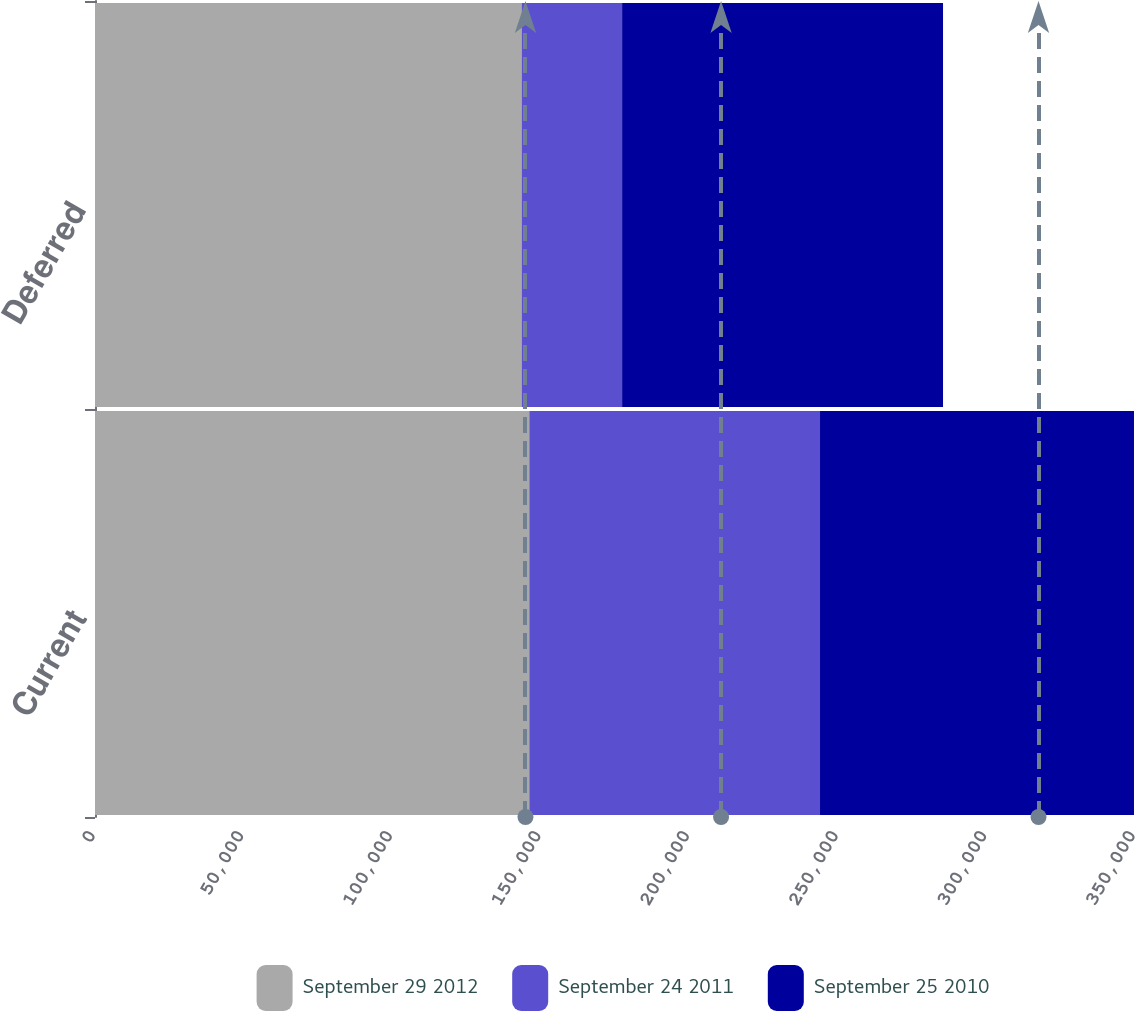Convert chart to OTSL. <chart><loc_0><loc_0><loc_500><loc_500><stacked_bar_chart><ecel><fcel>Current<fcel>Deferred<nl><fcel>September 29 2012<fcel>146164<fcel>143582<nl><fcel>September 24 2011<fcel>97834<fcel>33808<nl><fcel>September 25 2010<fcel>105664<fcel>108002<nl></chart> 